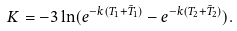Convert formula to latex. <formula><loc_0><loc_0><loc_500><loc_500>K = - 3 \ln ( e ^ { - k ( T _ { 1 } + \bar { T } _ { 1 } ) } - e ^ { - k ( T _ { 2 } + \bar { T } _ { 2 } ) } ) .</formula> 